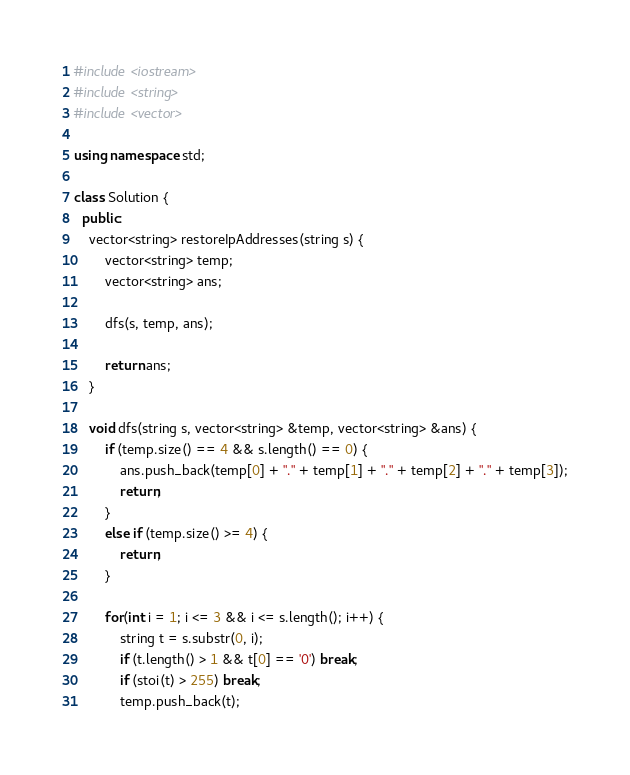<code> <loc_0><loc_0><loc_500><loc_500><_C++_>#include <iostream>
#include <string>
#include <vector>

using namespace std;

class Solution {
  public:
    vector<string> restoreIpAddresses(string s) {
        vector<string> temp;
        vector<string> ans;

        dfs(s, temp, ans);

        return ans;
    }

    void dfs(string s, vector<string> &temp, vector<string> &ans) {
        if (temp.size() == 4 && s.length() == 0) {
            ans.push_back(temp[0] + "." + temp[1] + "." + temp[2] + "." + temp[3]);
            return;
        }
        else if (temp.size() >= 4) {
            return;
        }

        for(int i = 1; i <= 3 && i <= s.length(); i++) {
            string t = s.substr(0, i);
            if (t.length() > 1 && t[0] == '0') break;
            if (stoi(t) > 255) break;
            temp.push_back(t);</code> 